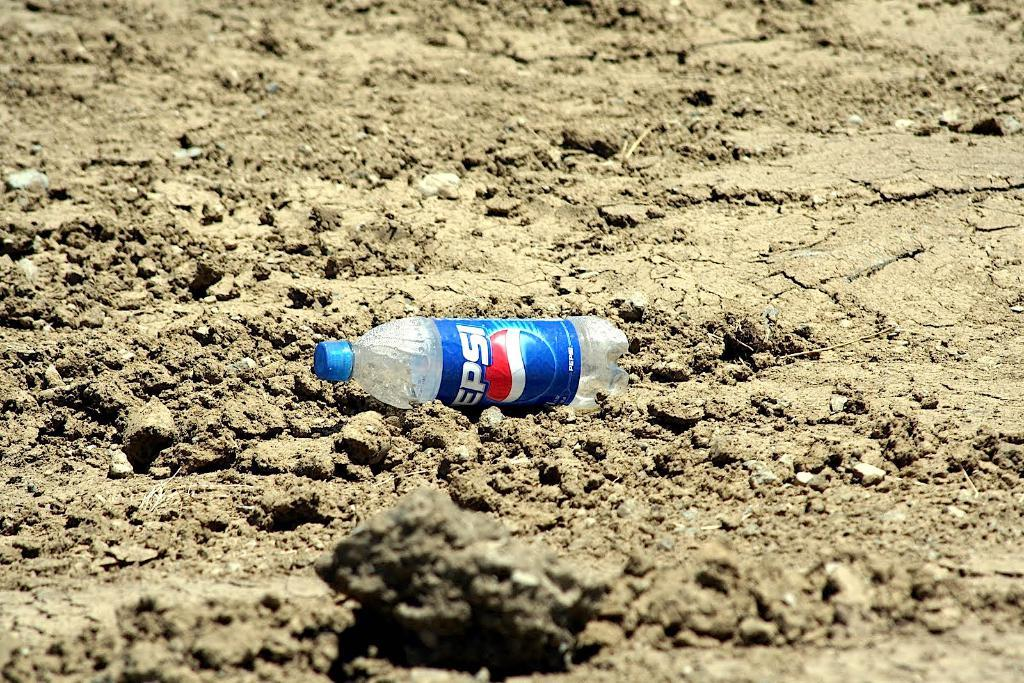<image>
Give a short and clear explanation of the subsequent image. An empty bottle of Pepsi is laying on the ground. 